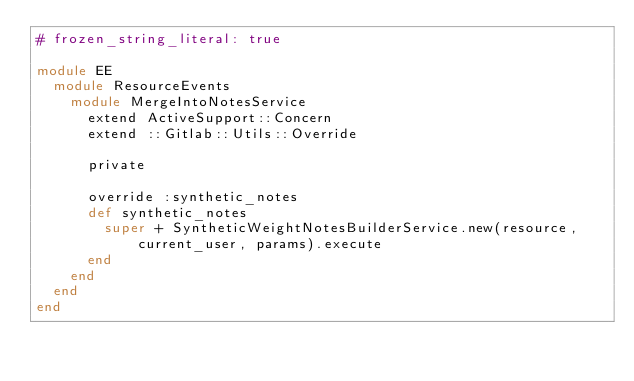<code> <loc_0><loc_0><loc_500><loc_500><_Ruby_># frozen_string_literal: true

module EE
  module ResourceEvents
    module MergeIntoNotesService
      extend ActiveSupport::Concern
      extend ::Gitlab::Utils::Override

      private

      override :synthetic_notes
      def synthetic_notes
        super + SyntheticWeightNotesBuilderService.new(resource, current_user, params).execute
      end
    end
  end
end
</code> 